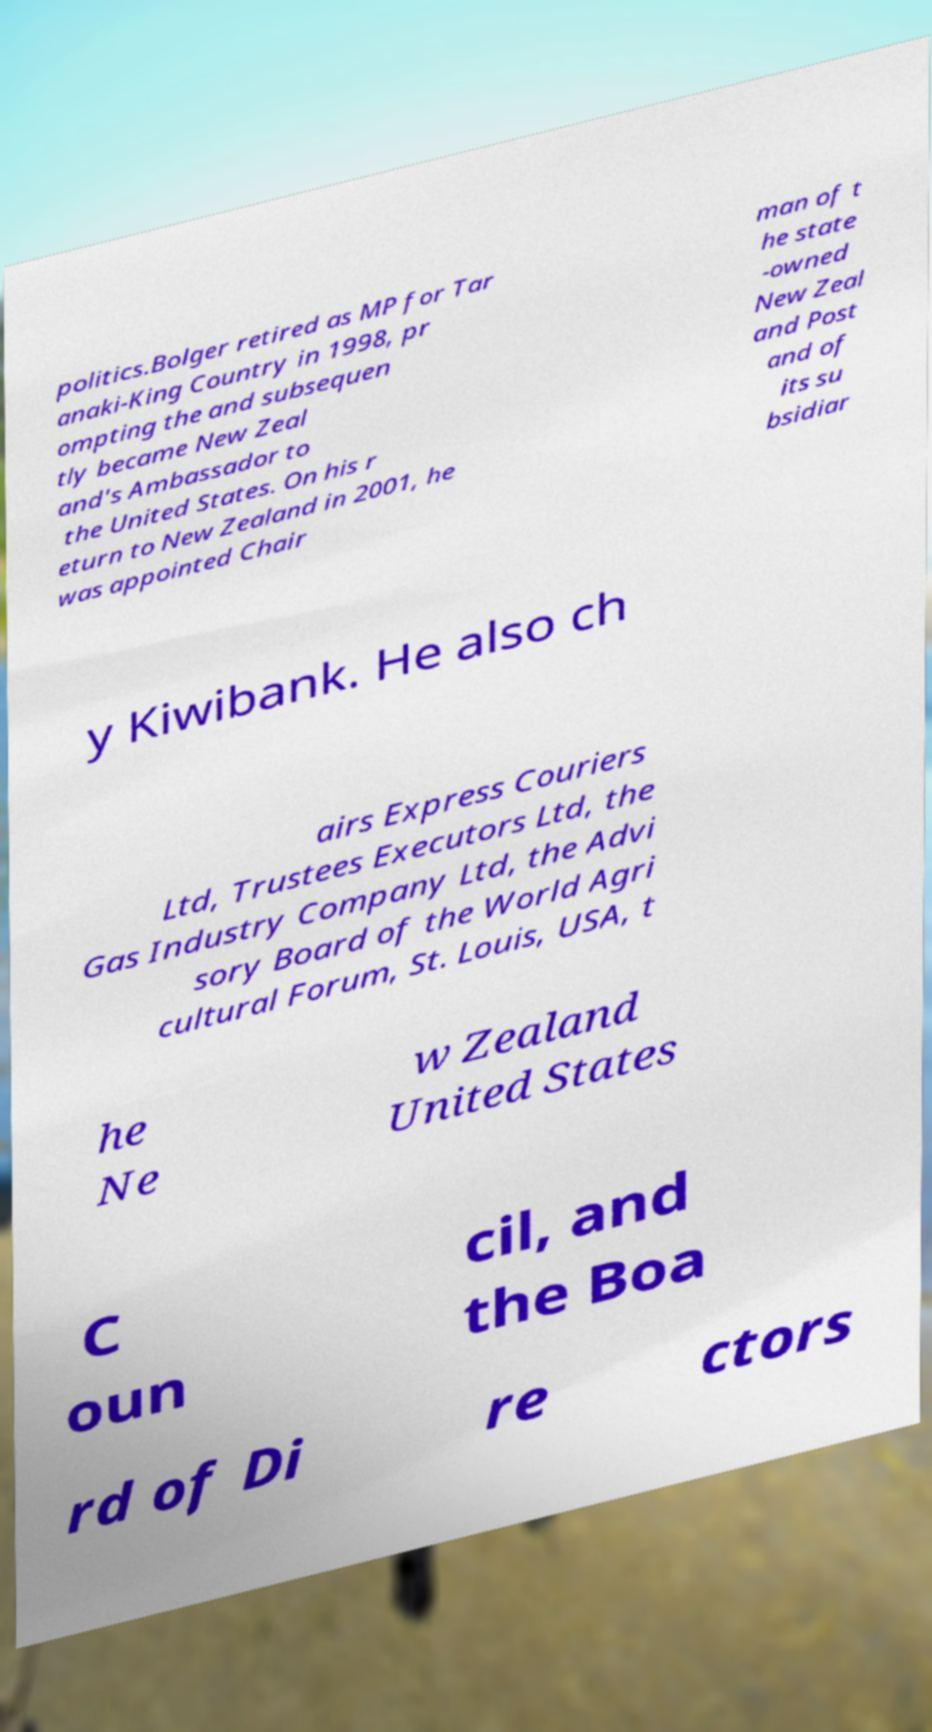For documentation purposes, I need the text within this image transcribed. Could you provide that? politics.Bolger retired as MP for Tar anaki-King Country in 1998, pr ompting the and subsequen tly became New Zeal and's Ambassador to the United States. On his r eturn to New Zealand in 2001, he was appointed Chair man of t he state -owned New Zeal and Post and of its su bsidiar y Kiwibank. He also ch airs Express Couriers Ltd, Trustees Executors Ltd, the Gas Industry Company Ltd, the Advi sory Board of the World Agri cultural Forum, St. Louis, USA, t he Ne w Zealand United States C oun cil, and the Boa rd of Di re ctors 